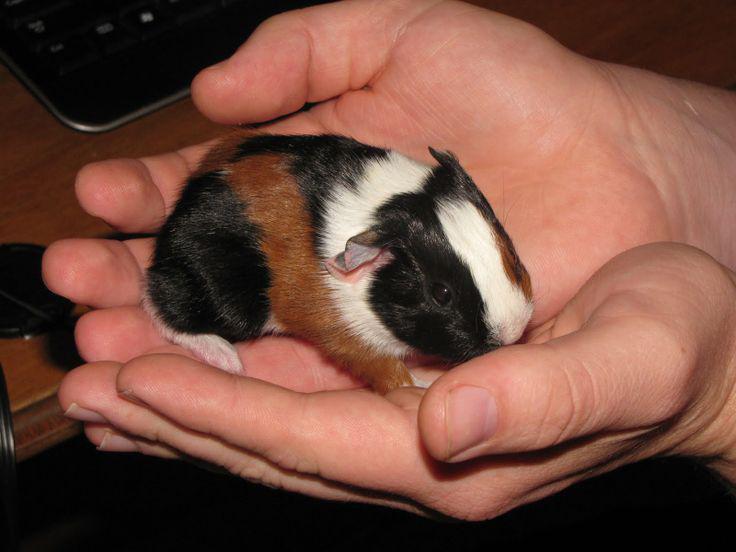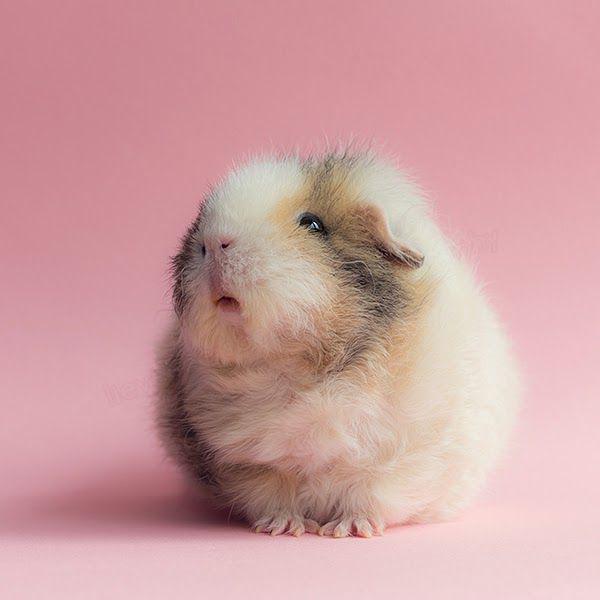The first image is the image on the left, the second image is the image on the right. Analyze the images presented: Is the assertion "In one of the images there is a pair of cupped hands holding a baby guinea pig." valid? Answer yes or no. Yes. The first image is the image on the left, the second image is the image on the right. Considering the images on both sides, is "Left image shows a pair of hands holding a tri-colored hamster." valid? Answer yes or no. Yes. 